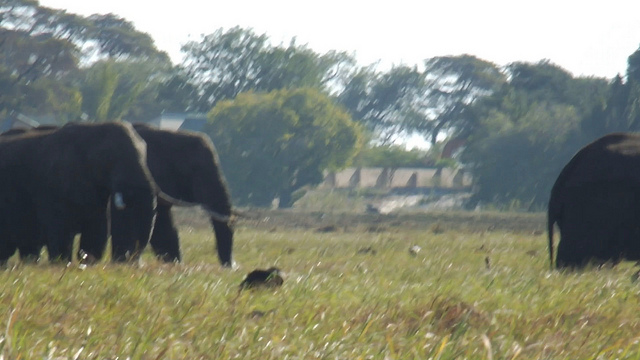<image>What is the house made out of? I am not sure what the house is made out of. It can be made from 'wood', 'concrete', 'brick', or 'cement'. What is the house made out of? I am not sure what the house is made out of. It can be made of wood, concrete, bricks, or cement. 